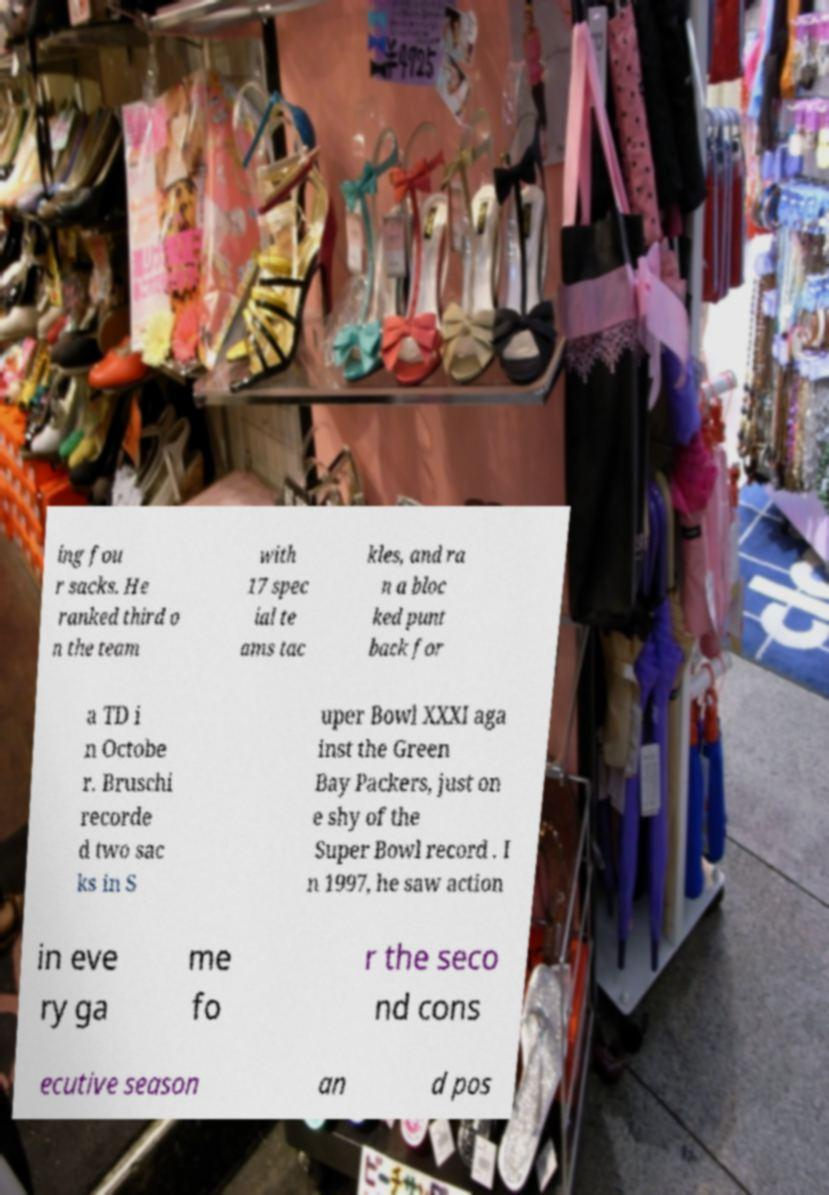Could you extract and type out the text from this image? ing fou r sacks. He ranked third o n the team with 17 spec ial te ams tac kles, and ra n a bloc ked punt back for a TD i n Octobe r. Bruschi recorde d two sac ks in S uper Bowl XXXI aga inst the Green Bay Packers, just on e shy of the Super Bowl record . I n 1997, he saw action in eve ry ga me fo r the seco nd cons ecutive season an d pos 